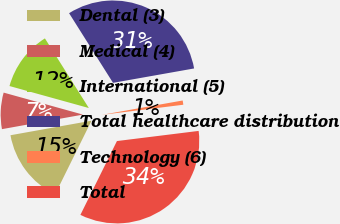<chart> <loc_0><loc_0><loc_500><loc_500><pie_chart><fcel>Dental (3)<fcel>Medical (4)<fcel>International (5)<fcel>Total healthcare distribution<fcel>Technology (6)<fcel>Total<nl><fcel>14.86%<fcel>7.13%<fcel>11.74%<fcel>31.16%<fcel>0.83%<fcel>34.28%<nl></chart> 